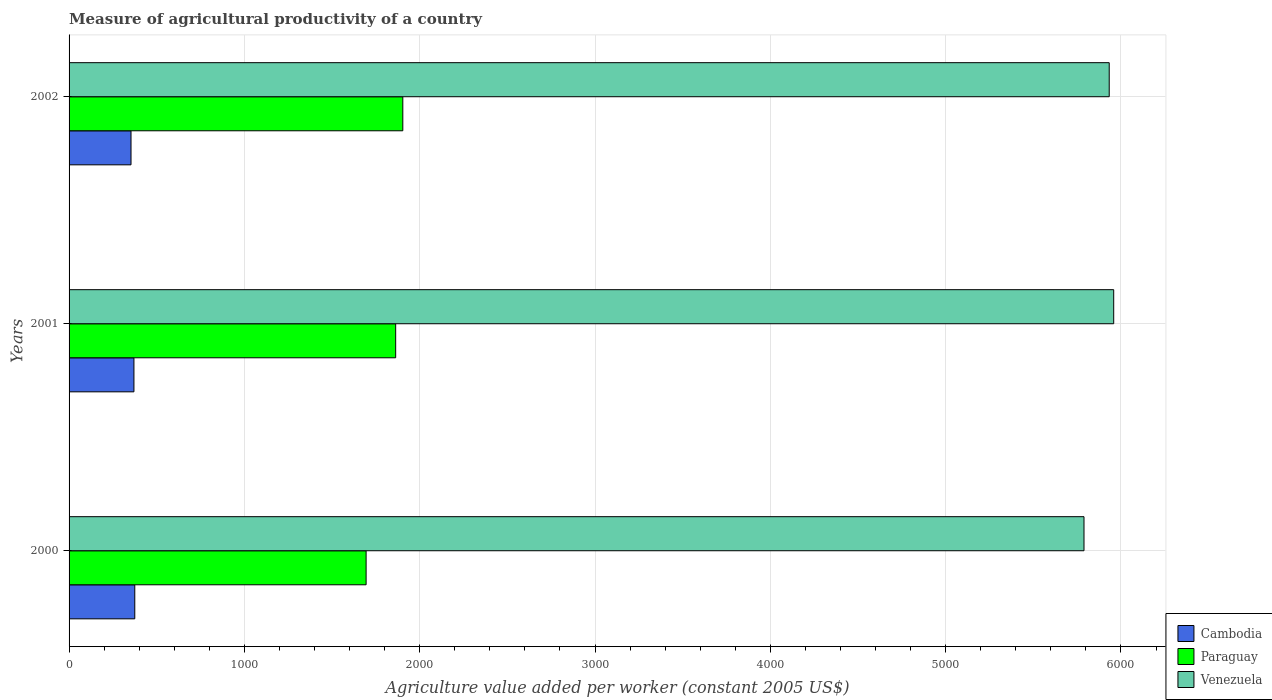How many groups of bars are there?
Keep it short and to the point. 3. Are the number of bars per tick equal to the number of legend labels?
Keep it short and to the point. Yes. How many bars are there on the 3rd tick from the top?
Provide a succinct answer. 3. How many bars are there on the 2nd tick from the bottom?
Keep it short and to the point. 3. What is the measure of agricultural productivity in Paraguay in 2002?
Your response must be concise. 1903.63. Across all years, what is the maximum measure of agricultural productivity in Cambodia?
Ensure brevity in your answer.  374.78. Across all years, what is the minimum measure of agricultural productivity in Paraguay?
Your answer should be very brief. 1694.29. In which year was the measure of agricultural productivity in Paraguay maximum?
Give a very brief answer. 2002. In which year was the measure of agricultural productivity in Venezuela minimum?
Offer a terse response. 2000. What is the total measure of agricultural productivity in Paraguay in the graph?
Provide a short and direct response. 5460.81. What is the difference between the measure of agricultural productivity in Paraguay in 2000 and that in 2002?
Make the answer very short. -209.34. What is the difference between the measure of agricultural productivity in Venezuela in 2000 and the measure of agricultural productivity in Paraguay in 2001?
Offer a terse response. 3926.28. What is the average measure of agricultural productivity in Venezuela per year?
Offer a very short reply. 5893.55. In the year 2000, what is the difference between the measure of agricultural productivity in Paraguay and measure of agricultural productivity in Cambodia?
Give a very brief answer. 1319.51. What is the ratio of the measure of agricultural productivity in Venezuela in 2001 to that in 2002?
Give a very brief answer. 1. Is the difference between the measure of agricultural productivity in Paraguay in 2000 and 2002 greater than the difference between the measure of agricultural productivity in Cambodia in 2000 and 2002?
Give a very brief answer. No. What is the difference between the highest and the second highest measure of agricultural productivity in Venezuela?
Your response must be concise. 25.53. What is the difference between the highest and the lowest measure of agricultural productivity in Cambodia?
Offer a very short reply. 21.49. What does the 2nd bar from the top in 2002 represents?
Give a very brief answer. Paraguay. What does the 2nd bar from the bottom in 2000 represents?
Your answer should be compact. Paraguay. Is it the case that in every year, the sum of the measure of agricultural productivity in Cambodia and measure of agricultural productivity in Venezuela is greater than the measure of agricultural productivity in Paraguay?
Give a very brief answer. Yes. How many bars are there?
Provide a succinct answer. 9. How many years are there in the graph?
Make the answer very short. 3. Where does the legend appear in the graph?
Make the answer very short. Bottom right. How are the legend labels stacked?
Make the answer very short. Vertical. What is the title of the graph?
Your answer should be compact. Measure of agricultural productivity of a country. What is the label or title of the X-axis?
Your response must be concise. Agriculture value added per worker (constant 2005 US$). What is the Agriculture value added per worker (constant 2005 US$) in Cambodia in 2000?
Provide a succinct answer. 374.78. What is the Agriculture value added per worker (constant 2005 US$) of Paraguay in 2000?
Your answer should be very brief. 1694.29. What is the Agriculture value added per worker (constant 2005 US$) in Venezuela in 2000?
Offer a very short reply. 5789.16. What is the Agriculture value added per worker (constant 2005 US$) in Cambodia in 2001?
Offer a terse response. 370.02. What is the Agriculture value added per worker (constant 2005 US$) in Paraguay in 2001?
Make the answer very short. 1862.88. What is the Agriculture value added per worker (constant 2005 US$) in Venezuela in 2001?
Give a very brief answer. 5958.51. What is the Agriculture value added per worker (constant 2005 US$) in Cambodia in 2002?
Offer a very short reply. 353.29. What is the Agriculture value added per worker (constant 2005 US$) of Paraguay in 2002?
Provide a succinct answer. 1903.63. What is the Agriculture value added per worker (constant 2005 US$) of Venezuela in 2002?
Offer a very short reply. 5932.98. Across all years, what is the maximum Agriculture value added per worker (constant 2005 US$) in Cambodia?
Provide a short and direct response. 374.78. Across all years, what is the maximum Agriculture value added per worker (constant 2005 US$) of Paraguay?
Provide a succinct answer. 1903.63. Across all years, what is the maximum Agriculture value added per worker (constant 2005 US$) of Venezuela?
Your answer should be compact. 5958.51. Across all years, what is the minimum Agriculture value added per worker (constant 2005 US$) of Cambodia?
Your response must be concise. 353.29. Across all years, what is the minimum Agriculture value added per worker (constant 2005 US$) in Paraguay?
Offer a very short reply. 1694.29. Across all years, what is the minimum Agriculture value added per worker (constant 2005 US$) of Venezuela?
Make the answer very short. 5789.16. What is the total Agriculture value added per worker (constant 2005 US$) of Cambodia in the graph?
Make the answer very short. 1098.1. What is the total Agriculture value added per worker (constant 2005 US$) of Paraguay in the graph?
Your response must be concise. 5460.81. What is the total Agriculture value added per worker (constant 2005 US$) in Venezuela in the graph?
Make the answer very short. 1.77e+04. What is the difference between the Agriculture value added per worker (constant 2005 US$) in Cambodia in 2000 and that in 2001?
Your response must be concise. 4.76. What is the difference between the Agriculture value added per worker (constant 2005 US$) of Paraguay in 2000 and that in 2001?
Make the answer very short. -168.59. What is the difference between the Agriculture value added per worker (constant 2005 US$) in Venezuela in 2000 and that in 2001?
Ensure brevity in your answer.  -169.36. What is the difference between the Agriculture value added per worker (constant 2005 US$) in Cambodia in 2000 and that in 2002?
Your answer should be very brief. 21.49. What is the difference between the Agriculture value added per worker (constant 2005 US$) of Paraguay in 2000 and that in 2002?
Give a very brief answer. -209.34. What is the difference between the Agriculture value added per worker (constant 2005 US$) in Venezuela in 2000 and that in 2002?
Make the answer very short. -143.82. What is the difference between the Agriculture value added per worker (constant 2005 US$) in Cambodia in 2001 and that in 2002?
Give a very brief answer. 16.73. What is the difference between the Agriculture value added per worker (constant 2005 US$) of Paraguay in 2001 and that in 2002?
Your response must be concise. -40.75. What is the difference between the Agriculture value added per worker (constant 2005 US$) of Venezuela in 2001 and that in 2002?
Provide a succinct answer. 25.53. What is the difference between the Agriculture value added per worker (constant 2005 US$) in Cambodia in 2000 and the Agriculture value added per worker (constant 2005 US$) in Paraguay in 2001?
Your answer should be compact. -1488.1. What is the difference between the Agriculture value added per worker (constant 2005 US$) of Cambodia in 2000 and the Agriculture value added per worker (constant 2005 US$) of Venezuela in 2001?
Offer a very short reply. -5583.73. What is the difference between the Agriculture value added per worker (constant 2005 US$) in Paraguay in 2000 and the Agriculture value added per worker (constant 2005 US$) in Venezuela in 2001?
Your answer should be compact. -4264.22. What is the difference between the Agriculture value added per worker (constant 2005 US$) in Cambodia in 2000 and the Agriculture value added per worker (constant 2005 US$) in Paraguay in 2002?
Provide a succinct answer. -1528.85. What is the difference between the Agriculture value added per worker (constant 2005 US$) of Cambodia in 2000 and the Agriculture value added per worker (constant 2005 US$) of Venezuela in 2002?
Your answer should be compact. -5558.19. What is the difference between the Agriculture value added per worker (constant 2005 US$) in Paraguay in 2000 and the Agriculture value added per worker (constant 2005 US$) in Venezuela in 2002?
Your answer should be compact. -4238.69. What is the difference between the Agriculture value added per worker (constant 2005 US$) of Cambodia in 2001 and the Agriculture value added per worker (constant 2005 US$) of Paraguay in 2002?
Your response must be concise. -1533.61. What is the difference between the Agriculture value added per worker (constant 2005 US$) of Cambodia in 2001 and the Agriculture value added per worker (constant 2005 US$) of Venezuela in 2002?
Provide a succinct answer. -5562.96. What is the difference between the Agriculture value added per worker (constant 2005 US$) of Paraguay in 2001 and the Agriculture value added per worker (constant 2005 US$) of Venezuela in 2002?
Give a very brief answer. -4070.1. What is the average Agriculture value added per worker (constant 2005 US$) of Cambodia per year?
Keep it short and to the point. 366.03. What is the average Agriculture value added per worker (constant 2005 US$) in Paraguay per year?
Offer a terse response. 1820.27. What is the average Agriculture value added per worker (constant 2005 US$) in Venezuela per year?
Ensure brevity in your answer.  5893.55. In the year 2000, what is the difference between the Agriculture value added per worker (constant 2005 US$) of Cambodia and Agriculture value added per worker (constant 2005 US$) of Paraguay?
Give a very brief answer. -1319.51. In the year 2000, what is the difference between the Agriculture value added per worker (constant 2005 US$) of Cambodia and Agriculture value added per worker (constant 2005 US$) of Venezuela?
Give a very brief answer. -5414.37. In the year 2000, what is the difference between the Agriculture value added per worker (constant 2005 US$) of Paraguay and Agriculture value added per worker (constant 2005 US$) of Venezuela?
Your response must be concise. -4094.86. In the year 2001, what is the difference between the Agriculture value added per worker (constant 2005 US$) in Cambodia and Agriculture value added per worker (constant 2005 US$) in Paraguay?
Give a very brief answer. -1492.86. In the year 2001, what is the difference between the Agriculture value added per worker (constant 2005 US$) of Cambodia and Agriculture value added per worker (constant 2005 US$) of Venezuela?
Ensure brevity in your answer.  -5588.49. In the year 2001, what is the difference between the Agriculture value added per worker (constant 2005 US$) of Paraguay and Agriculture value added per worker (constant 2005 US$) of Venezuela?
Your response must be concise. -4095.63. In the year 2002, what is the difference between the Agriculture value added per worker (constant 2005 US$) in Cambodia and Agriculture value added per worker (constant 2005 US$) in Paraguay?
Keep it short and to the point. -1550.34. In the year 2002, what is the difference between the Agriculture value added per worker (constant 2005 US$) in Cambodia and Agriculture value added per worker (constant 2005 US$) in Venezuela?
Offer a terse response. -5579.69. In the year 2002, what is the difference between the Agriculture value added per worker (constant 2005 US$) of Paraguay and Agriculture value added per worker (constant 2005 US$) of Venezuela?
Your answer should be compact. -4029.34. What is the ratio of the Agriculture value added per worker (constant 2005 US$) in Cambodia in 2000 to that in 2001?
Provide a succinct answer. 1.01. What is the ratio of the Agriculture value added per worker (constant 2005 US$) of Paraguay in 2000 to that in 2001?
Keep it short and to the point. 0.91. What is the ratio of the Agriculture value added per worker (constant 2005 US$) in Venezuela in 2000 to that in 2001?
Give a very brief answer. 0.97. What is the ratio of the Agriculture value added per worker (constant 2005 US$) of Cambodia in 2000 to that in 2002?
Keep it short and to the point. 1.06. What is the ratio of the Agriculture value added per worker (constant 2005 US$) in Paraguay in 2000 to that in 2002?
Ensure brevity in your answer.  0.89. What is the ratio of the Agriculture value added per worker (constant 2005 US$) of Venezuela in 2000 to that in 2002?
Offer a very short reply. 0.98. What is the ratio of the Agriculture value added per worker (constant 2005 US$) of Cambodia in 2001 to that in 2002?
Your response must be concise. 1.05. What is the ratio of the Agriculture value added per worker (constant 2005 US$) of Paraguay in 2001 to that in 2002?
Your response must be concise. 0.98. What is the ratio of the Agriculture value added per worker (constant 2005 US$) in Venezuela in 2001 to that in 2002?
Provide a succinct answer. 1. What is the difference between the highest and the second highest Agriculture value added per worker (constant 2005 US$) in Cambodia?
Offer a terse response. 4.76. What is the difference between the highest and the second highest Agriculture value added per worker (constant 2005 US$) of Paraguay?
Make the answer very short. 40.75. What is the difference between the highest and the second highest Agriculture value added per worker (constant 2005 US$) in Venezuela?
Your answer should be compact. 25.53. What is the difference between the highest and the lowest Agriculture value added per worker (constant 2005 US$) in Cambodia?
Give a very brief answer. 21.49. What is the difference between the highest and the lowest Agriculture value added per worker (constant 2005 US$) of Paraguay?
Your answer should be very brief. 209.34. What is the difference between the highest and the lowest Agriculture value added per worker (constant 2005 US$) of Venezuela?
Keep it short and to the point. 169.36. 